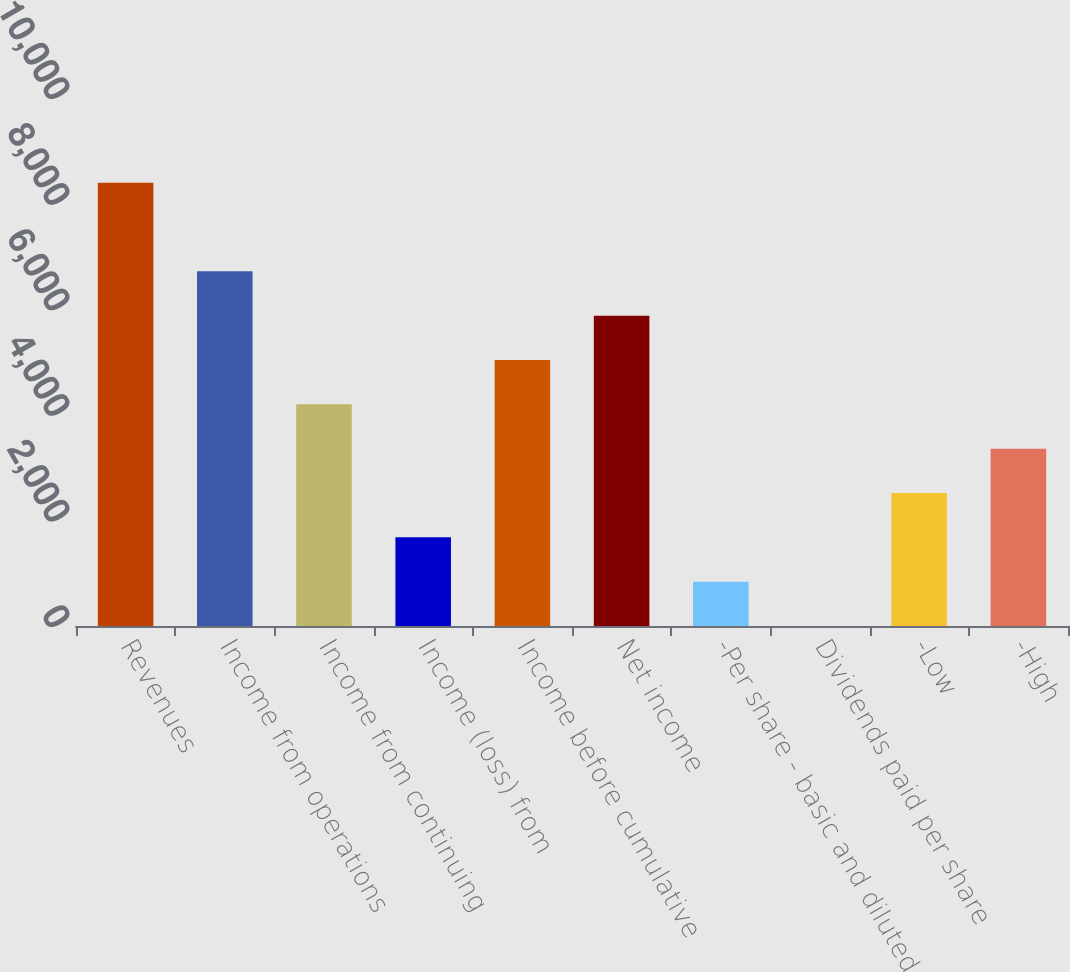Convert chart. <chart><loc_0><loc_0><loc_500><loc_500><bar_chart><fcel>Revenues<fcel>Income from operations<fcel>Income from continuing<fcel>Income (loss) from<fcel>Income before cumulative<fcel>Net income<fcel>-Per share - basic and diluted<fcel>Dividends paid per share<fcel>-Low<fcel>-High<nl><fcel>8397<fcel>6717.67<fcel>4198.63<fcel>1679.59<fcel>5038.31<fcel>5877.99<fcel>839.91<fcel>0.23<fcel>2519.27<fcel>3358.95<nl></chart> 